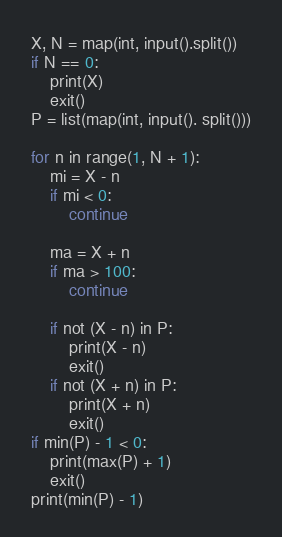Convert code to text. <code><loc_0><loc_0><loc_500><loc_500><_Python_>X, N = map(int, input().split())
if N == 0:
    print(X)
    exit()
P = list(map(int, input(). split()))

for n in range(1, N + 1):
    mi = X - n
    if mi < 0:
        continue

    ma = X + n
    if ma > 100:
        continue

    if not (X - n) in P:
        print(X - n)
        exit()
    if not (X + n) in P:
        print(X + n)
        exit()
if min(P) - 1 < 0:
    print(max(P) + 1)
    exit()
print(min(P) - 1)</code> 